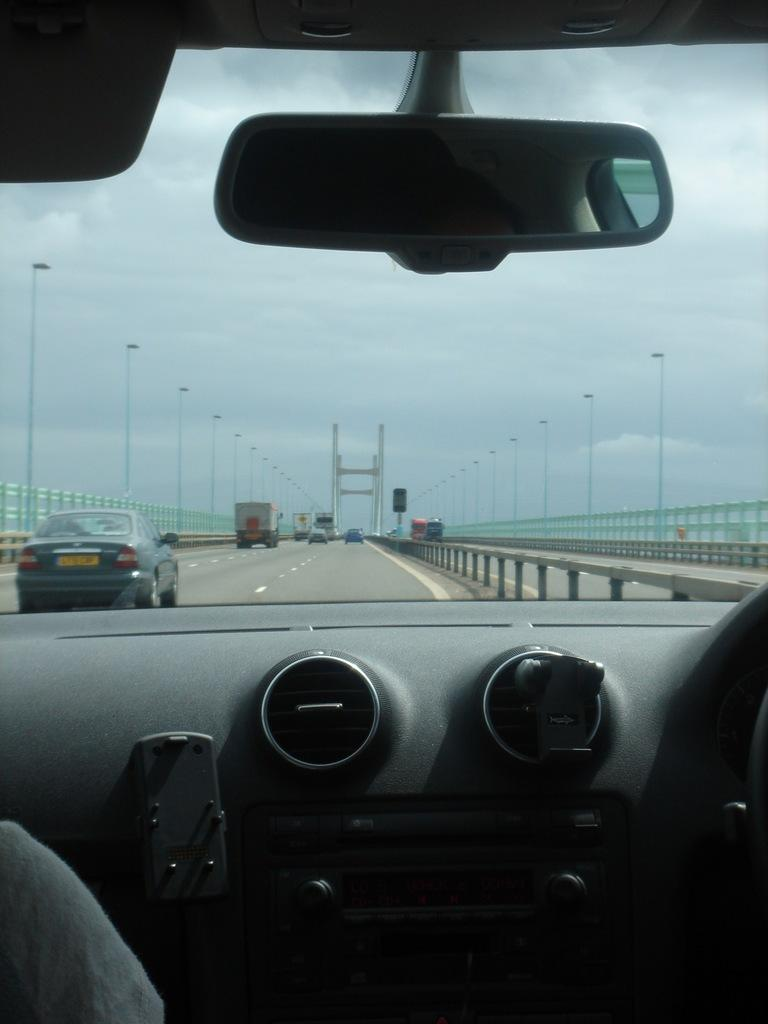What can be seen on the road in the image? There are vehicles on the road in the image. What is located beside the vehicles? There is a fence beside the vehicles. What structures are present in the image that provide illumination? There are light poles in the image. What type of reflection is shown in the image? This is a mirror. What is the condition of the sky in the image? The sky is cloudy in the image. How does the force of gravity affect the vehicles in the image? The force of gravity affects the vehicles in the image by keeping them on the ground, but this question cannot be answered definitively from the provided facts. What type of lift is present in the image? There is no lift present in the image; it features vehicles on a road. 